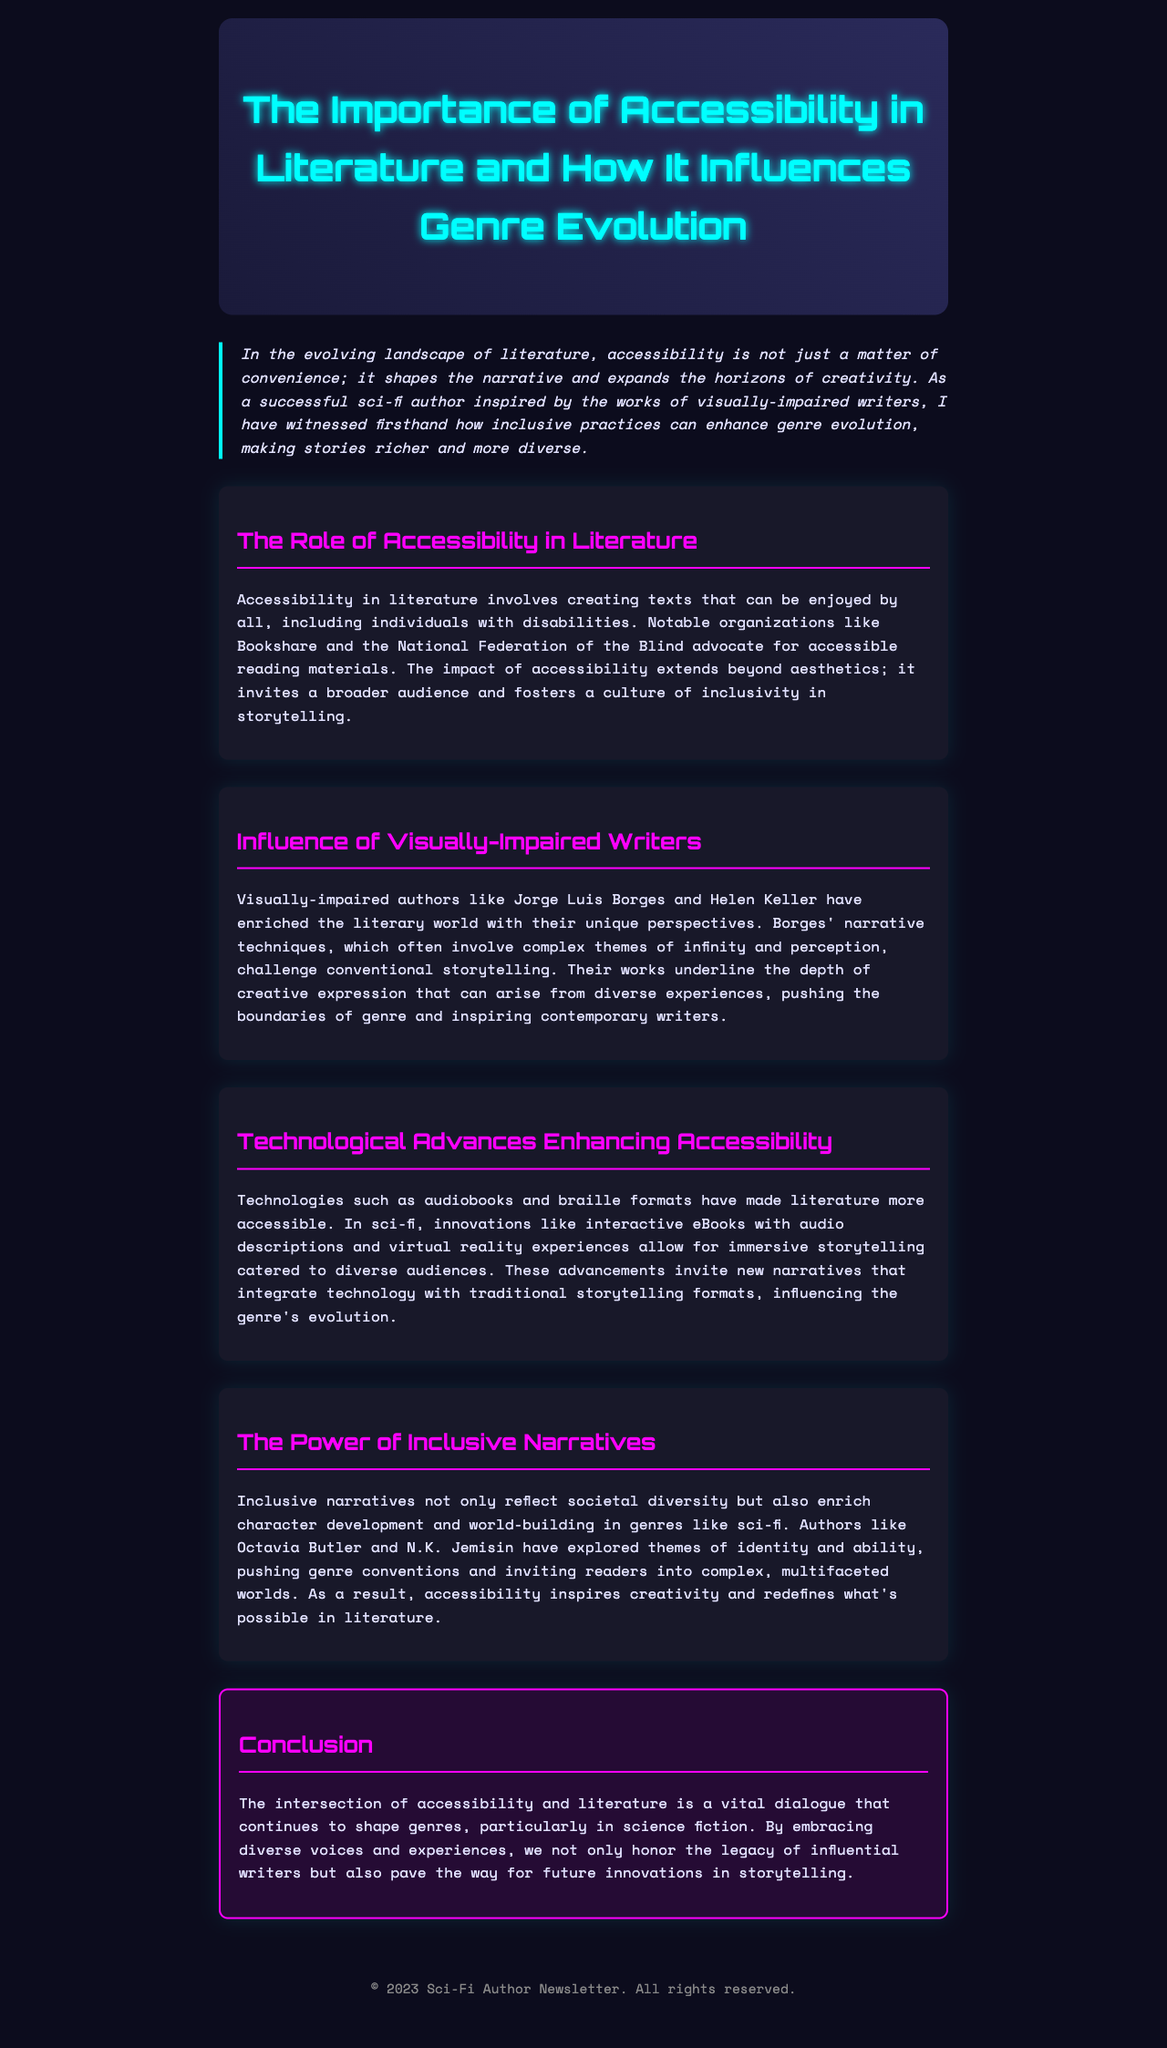what is the title of the newsletter? The title of the newsletter is prominently displayed in the header section of the document.
Answer: The Importance of Accessibility in Literature and How It Influences Genre Evolution who are two visually-impaired writers mentioned in the newsletter? The document specifically names two influential visually-impaired authors in the section discussing their contributions to literature.
Answer: Jorge Luis Borges and Helen Keller what role do organizations like Bookshare play in literature? The document states the function these organizations serve in relation to literature accessibility.
Answer: Advocate for accessible reading materials which technology is mentioned to enhance accessibility in literature? The document provides specific examples of technologies that have improved access to reading materials.
Answer: Audiobooks how does accessibility impact storytelling according to the newsletter? The text explains a broader implication of accessibility in relation to audience engagement and inclusivity.
Answer: Fosters a culture of inclusivity which genre does the newsletter focus on regarding the influence of accessibility? The document emphasizes a specific literary genre that has been notably shaped by accessibility and diverse voices.
Answer: Science fiction what kind of narratives enrich character development and world-building as per the document? The newsletter describes the characteristics of narratives that enhance literary depth within genres.
Answer: Inclusive narratives who are two contemporary authors mentioned that explore themes of identity and ability? The document cites modern authors who dive into complex themes that contribute to genre evolution.
Answer: Octavia Butler and N.K. Jemisin 